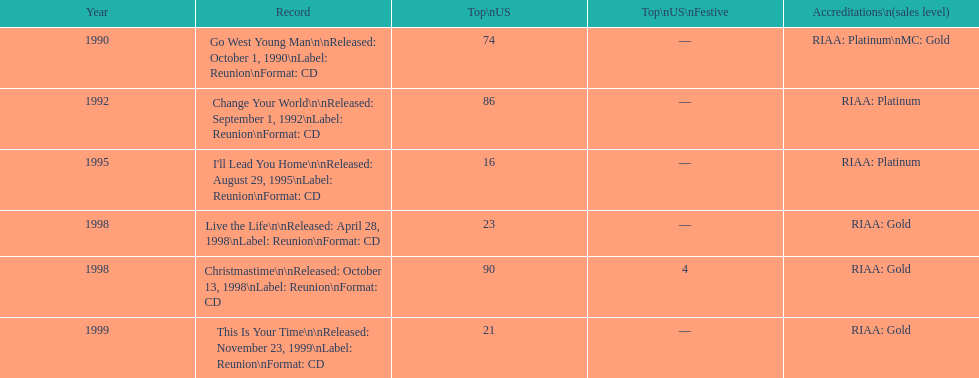How many album entries are there? 6. 